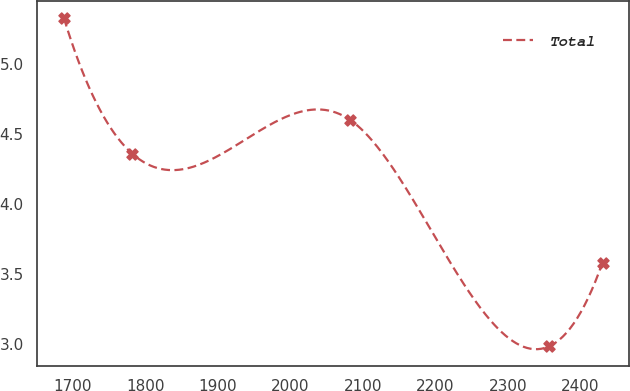Convert chart to OTSL. <chart><loc_0><loc_0><loc_500><loc_500><line_chart><ecel><fcel>Total<nl><fcel>1687.38<fcel>5.33<nl><fcel>1781.46<fcel>4.36<nl><fcel>2082.46<fcel>4.6<nl><fcel>2356.95<fcel>2.98<nl><fcel>2430.63<fcel>3.58<nl></chart> 